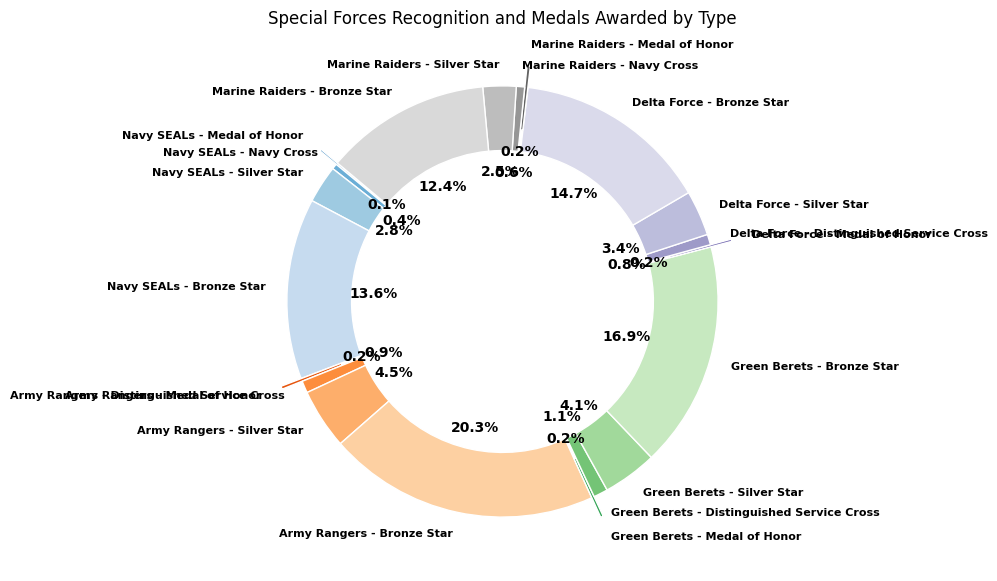Which Special Forces unit received the most Bronze Stars? By looking at the 'Bronze Star' sections on the ring chart, we can observe the lengths visually. The Army Rangers' section for the Bronze Star is the largest.
Answer: Army Rangers How many total Silver Stars were awarded across all units? Add the counts for Silver Stars across Navy SEALs (250), Army Rangers (400), Green Berets (360), Delta Force (300), and Marine Raiders (220): 250 + 400 + 360 + 300 + 220 = 1530.
Answer: 1530 Which unit received more Medal of Honors, Navy SEALs or Delta Force? Compare the sections of 'Medal of Honor' on the ring chart for Navy SEALs (12) and Delta Force (15). Delta Force has a larger portion.
Answer: Delta Force What is the percentage difference between the Bronze Stars awarded to Marine Raiders and Green Berets? The Marine Raiders received 1100 Bronze Stars and Green Berets received 1500 Bronze Stars. The difference is 1500 - 1100 = 400. To find the percentage difference relative to Marine Raiders: (400/1100) * 100 ≈ 36.36%.
Answer: 36.36% Which recognition type is represented with an exploded segment on the chart? The exploded segments of the ring chart are visually set apart. Upon inspection, only 'Medal of Honor' sections are exploded.
Answer: Medal of Honor How many more Navy Cross awards were given to Marine Raiders compared to Navy SEALs? The Marine Raiders received 55 Navy Cross awards and Navy SEALs received 36. The difference is 55 - 36 = 19.
Answer: 19 What is the combined total number of Medal of Honor awards for Navy SEALs and Marine Raiders? Add the Medal of Honor awards for Navy SEALs (12) and Marine Raiders (22): 12 + 22 = 34.
Answer: 34 Among the units, which has the smallest count of Distinguished Service Cross awards and what is the count? The Distinguished Service Cross sections show counts for Army Rangers, Green Berets, and Delta Force. Delta Force has the smallest count with 70 awards.
Answer: Delta Force, 70 How many units received more than 300 Silver Stars? From the counts of Silver Stars, Army Rangers (400), Green Berets (360), and Delta Force (300) can be counted. Three units received more than 300 Silver Stars.
Answer: 3 What is the most common recognition type across all units? By visually comparing the different sections, it is evident that 'Bronze Star' sections are the largest across all units, indicating it is the most common award.
Answer: Bronze Star 